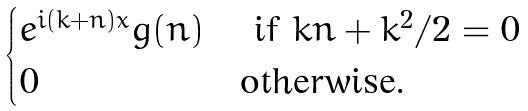<formula> <loc_0><loc_0><loc_500><loc_500>\begin{cases} e ^ { i ( k + n ) x } g ( n ) & \text { if $kn+k^{2}/2=0$} \\ 0 & \text {otherwise.} \\ \end{cases}</formula> 